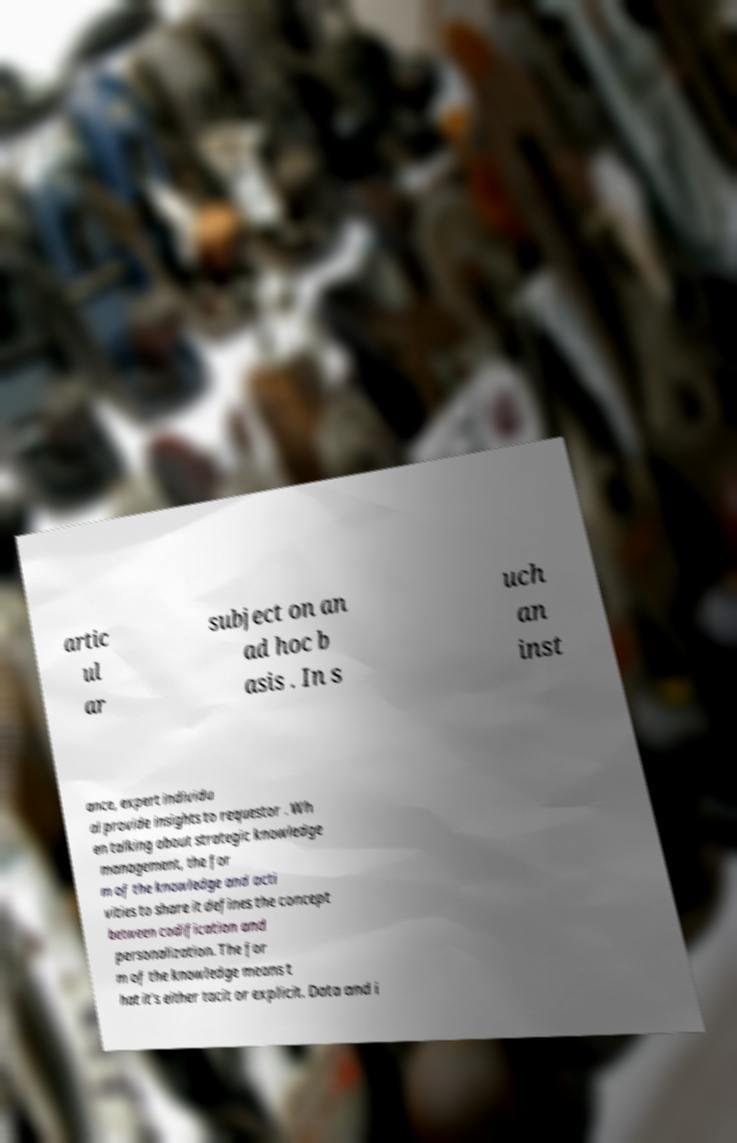Can you read and provide the text displayed in the image?This photo seems to have some interesting text. Can you extract and type it out for me? artic ul ar subject on an ad hoc b asis . In s uch an inst ance, expert individu al provide insights to requestor . Wh en talking about strategic knowledge management, the for m of the knowledge and acti vities to share it defines the concept between codification and personalization. The for m of the knowledge means t hat it’s either tacit or explicit. Data and i 